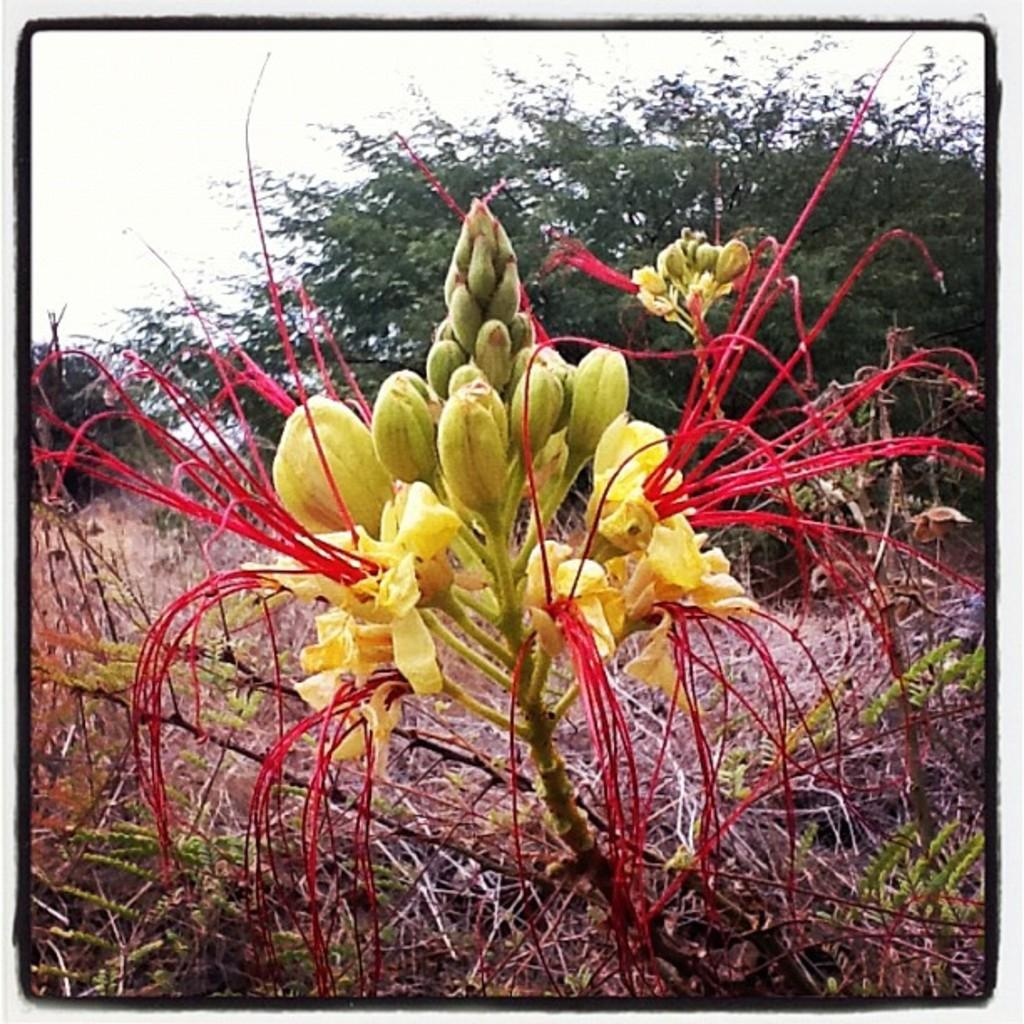What type of plants can be seen in the image? There are flowers with buds and stems in the image. What is the surface on which the flowers are placed? There is grass on the surface in the image. What other types of plants are visible in the image? There are trees visible in the image. What color is the grape hanging from the tree in the image? There is no grape present in the image; it only features flowers, grass, and trees. 